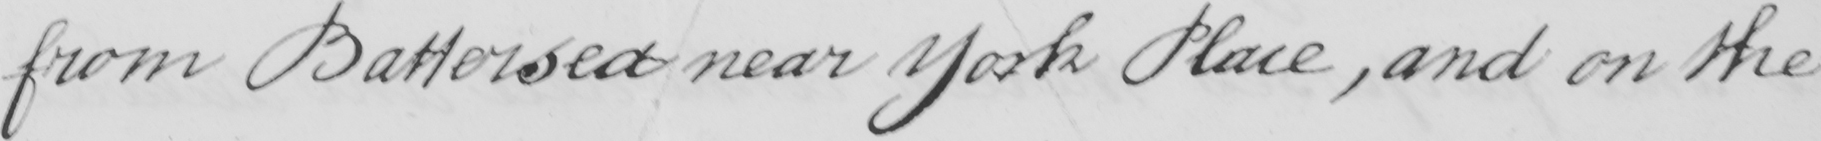Can you read and transcribe this handwriting? from Battersea near York Place , and on the 